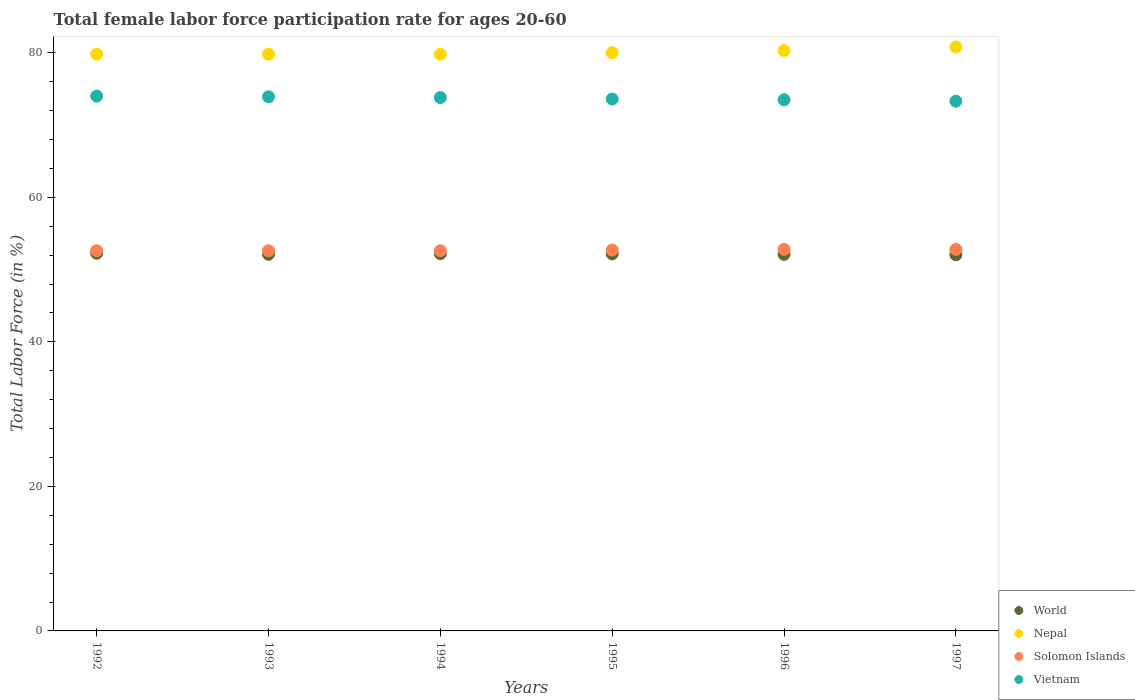How many different coloured dotlines are there?
Your answer should be compact. 4. Is the number of dotlines equal to the number of legend labels?
Keep it short and to the point. Yes. Across all years, what is the maximum female labor force participation rate in World?
Provide a succinct answer. 52.26. Across all years, what is the minimum female labor force participation rate in Solomon Islands?
Your answer should be compact. 52.6. What is the total female labor force participation rate in Nepal in the graph?
Offer a terse response. 480.5. What is the difference between the female labor force participation rate in World in 1995 and that in 1996?
Your answer should be compact. 0.07. What is the difference between the female labor force participation rate in Solomon Islands in 1992 and the female labor force participation rate in Nepal in 1995?
Give a very brief answer. -27.4. What is the average female labor force participation rate in Vietnam per year?
Your response must be concise. 73.68. In the year 1995, what is the difference between the female labor force participation rate in World and female labor force participation rate in Nepal?
Provide a succinct answer. -27.83. What is the ratio of the female labor force participation rate in World in 1992 to that in 1994?
Offer a very short reply. 1. Is the female labor force participation rate in Nepal in 1993 less than that in 1996?
Your response must be concise. Yes. Is the difference between the female labor force participation rate in World in 1993 and 1994 greater than the difference between the female labor force participation rate in Nepal in 1993 and 1994?
Provide a short and direct response. No. What is the difference between the highest and the lowest female labor force participation rate in Solomon Islands?
Your answer should be compact. 0.2. In how many years, is the female labor force participation rate in Nepal greater than the average female labor force participation rate in Nepal taken over all years?
Provide a succinct answer. 2. Does the female labor force participation rate in Vietnam monotonically increase over the years?
Give a very brief answer. No. How many years are there in the graph?
Make the answer very short. 6. Does the graph contain grids?
Your answer should be compact. No. Where does the legend appear in the graph?
Offer a very short reply. Bottom right. How many legend labels are there?
Provide a short and direct response. 4. How are the legend labels stacked?
Your answer should be very brief. Vertical. What is the title of the graph?
Offer a terse response. Total female labor force participation rate for ages 20-60. What is the label or title of the X-axis?
Give a very brief answer. Years. What is the label or title of the Y-axis?
Keep it short and to the point. Total Labor Force (in %). What is the Total Labor Force (in %) of World in 1992?
Provide a short and direct response. 52.26. What is the Total Labor Force (in %) of Nepal in 1992?
Ensure brevity in your answer.  79.8. What is the Total Labor Force (in %) of Solomon Islands in 1992?
Provide a succinct answer. 52.6. What is the Total Labor Force (in %) of World in 1993?
Make the answer very short. 52.11. What is the Total Labor Force (in %) in Nepal in 1993?
Your response must be concise. 79.8. What is the Total Labor Force (in %) in Solomon Islands in 1993?
Provide a succinct answer. 52.6. What is the Total Labor Force (in %) in Vietnam in 1993?
Offer a terse response. 73.9. What is the Total Labor Force (in %) of World in 1994?
Offer a terse response. 52.2. What is the Total Labor Force (in %) of Nepal in 1994?
Make the answer very short. 79.8. What is the Total Labor Force (in %) of Solomon Islands in 1994?
Offer a terse response. 52.6. What is the Total Labor Force (in %) in Vietnam in 1994?
Your response must be concise. 73.8. What is the Total Labor Force (in %) in World in 1995?
Give a very brief answer. 52.17. What is the Total Labor Force (in %) in Solomon Islands in 1995?
Offer a terse response. 52.7. What is the Total Labor Force (in %) of Vietnam in 1995?
Give a very brief answer. 73.6. What is the Total Labor Force (in %) of World in 1996?
Your answer should be very brief. 52.1. What is the Total Labor Force (in %) of Nepal in 1996?
Your answer should be compact. 80.3. What is the Total Labor Force (in %) in Solomon Islands in 1996?
Your answer should be compact. 52.8. What is the Total Labor Force (in %) of Vietnam in 1996?
Your answer should be compact. 73.5. What is the Total Labor Force (in %) of World in 1997?
Offer a very short reply. 52.04. What is the Total Labor Force (in %) of Nepal in 1997?
Offer a terse response. 80.8. What is the Total Labor Force (in %) in Solomon Islands in 1997?
Your answer should be compact. 52.8. What is the Total Labor Force (in %) of Vietnam in 1997?
Ensure brevity in your answer.  73.3. Across all years, what is the maximum Total Labor Force (in %) of World?
Offer a terse response. 52.26. Across all years, what is the maximum Total Labor Force (in %) in Nepal?
Give a very brief answer. 80.8. Across all years, what is the maximum Total Labor Force (in %) in Solomon Islands?
Your answer should be very brief. 52.8. Across all years, what is the maximum Total Labor Force (in %) of Vietnam?
Your response must be concise. 74. Across all years, what is the minimum Total Labor Force (in %) in World?
Your response must be concise. 52.04. Across all years, what is the minimum Total Labor Force (in %) in Nepal?
Ensure brevity in your answer.  79.8. Across all years, what is the minimum Total Labor Force (in %) of Solomon Islands?
Offer a very short reply. 52.6. Across all years, what is the minimum Total Labor Force (in %) in Vietnam?
Your answer should be very brief. 73.3. What is the total Total Labor Force (in %) in World in the graph?
Make the answer very short. 312.89. What is the total Total Labor Force (in %) of Nepal in the graph?
Ensure brevity in your answer.  480.5. What is the total Total Labor Force (in %) in Solomon Islands in the graph?
Provide a succinct answer. 316.1. What is the total Total Labor Force (in %) of Vietnam in the graph?
Your answer should be very brief. 442.1. What is the difference between the Total Labor Force (in %) of World in 1992 and that in 1993?
Your answer should be very brief. 0.15. What is the difference between the Total Labor Force (in %) of Nepal in 1992 and that in 1993?
Provide a short and direct response. 0. What is the difference between the Total Labor Force (in %) of Solomon Islands in 1992 and that in 1993?
Offer a terse response. 0. What is the difference between the Total Labor Force (in %) of World in 1992 and that in 1994?
Your response must be concise. 0.06. What is the difference between the Total Labor Force (in %) in Vietnam in 1992 and that in 1994?
Offer a terse response. 0.2. What is the difference between the Total Labor Force (in %) in World in 1992 and that in 1995?
Ensure brevity in your answer.  0.09. What is the difference between the Total Labor Force (in %) of World in 1992 and that in 1996?
Offer a terse response. 0.16. What is the difference between the Total Labor Force (in %) of Nepal in 1992 and that in 1996?
Make the answer very short. -0.5. What is the difference between the Total Labor Force (in %) of Vietnam in 1992 and that in 1996?
Keep it short and to the point. 0.5. What is the difference between the Total Labor Force (in %) of World in 1992 and that in 1997?
Give a very brief answer. 0.21. What is the difference between the Total Labor Force (in %) in Nepal in 1992 and that in 1997?
Ensure brevity in your answer.  -1. What is the difference between the Total Labor Force (in %) in Vietnam in 1992 and that in 1997?
Your answer should be compact. 0.7. What is the difference between the Total Labor Force (in %) in World in 1993 and that in 1994?
Ensure brevity in your answer.  -0.09. What is the difference between the Total Labor Force (in %) of Nepal in 1993 and that in 1994?
Give a very brief answer. 0. What is the difference between the Total Labor Force (in %) of World in 1993 and that in 1995?
Make the answer very short. -0.06. What is the difference between the Total Labor Force (in %) in Nepal in 1993 and that in 1995?
Your response must be concise. -0.2. What is the difference between the Total Labor Force (in %) of World in 1993 and that in 1996?
Give a very brief answer. 0.01. What is the difference between the Total Labor Force (in %) in Solomon Islands in 1993 and that in 1996?
Offer a very short reply. -0.2. What is the difference between the Total Labor Force (in %) in World in 1993 and that in 1997?
Ensure brevity in your answer.  0.07. What is the difference between the Total Labor Force (in %) in Solomon Islands in 1993 and that in 1997?
Make the answer very short. -0.2. What is the difference between the Total Labor Force (in %) in Vietnam in 1993 and that in 1997?
Give a very brief answer. 0.6. What is the difference between the Total Labor Force (in %) in World in 1994 and that in 1995?
Provide a succinct answer. 0.03. What is the difference between the Total Labor Force (in %) of World in 1994 and that in 1996?
Offer a terse response. 0.1. What is the difference between the Total Labor Force (in %) in Nepal in 1994 and that in 1996?
Provide a succinct answer. -0.5. What is the difference between the Total Labor Force (in %) in World in 1994 and that in 1997?
Make the answer very short. 0.16. What is the difference between the Total Labor Force (in %) in Nepal in 1994 and that in 1997?
Offer a terse response. -1. What is the difference between the Total Labor Force (in %) in World in 1995 and that in 1996?
Offer a very short reply. 0.07. What is the difference between the Total Labor Force (in %) of Nepal in 1995 and that in 1996?
Ensure brevity in your answer.  -0.3. What is the difference between the Total Labor Force (in %) of Vietnam in 1995 and that in 1996?
Keep it short and to the point. 0.1. What is the difference between the Total Labor Force (in %) in World in 1995 and that in 1997?
Offer a terse response. 0.12. What is the difference between the Total Labor Force (in %) in Nepal in 1995 and that in 1997?
Keep it short and to the point. -0.8. What is the difference between the Total Labor Force (in %) of Vietnam in 1995 and that in 1997?
Provide a succinct answer. 0.3. What is the difference between the Total Labor Force (in %) of World in 1996 and that in 1997?
Your answer should be compact. 0.06. What is the difference between the Total Labor Force (in %) in World in 1992 and the Total Labor Force (in %) in Nepal in 1993?
Your answer should be very brief. -27.54. What is the difference between the Total Labor Force (in %) in World in 1992 and the Total Labor Force (in %) in Solomon Islands in 1993?
Offer a very short reply. -0.34. What is the difference between the Total Labor Force (in %) in World in 1992 and the Total Labor Force (in %) in Vietnam in 1993?
Your answer should be compact. -21.64. What is the difference between the Total Labor Force (in %) of Nepal in 1992 and the Total Labor Force (in %) of Solomon Islands in 1993?
Provide a succinct answer. 27.2. What is the difference between the Total Labor Force (in %) in Nepal in 1992 and the Total Labor Force (in %) in Vietnam in 1993?
Offer a terse response. 5.9. What is the difference between the Total Labor Force (in %) of Solomon Islands in 1992 and the Total Labor Force (in %) of Vietnam in 1993?
Ensure brevity in your answer.  -21.3. What is the difference between the Total Labor Force (in %) of World in 1992 and the Total Labor Force (in %) of Nepal in 1994?
Make the answer very short. -27.54. What is the difference between the Total Labor Force (in %) of World in 1992 and the Total Labor Force (in %) of Solomon Islands in 1994?
Your answer should be compact. -0.34. What is the difference between the Total Labor Force (in %) in World in 1992 and the Total Labor Force (in %) in Vietnam in 1994?
Ensure brevity in your answer.  -21.54. What is the difference between the Total Labor Force (in %) of Nepal in 1992 and the Total Labor Force (in %) of Solomon Islands in 1994?
Give a very brief answer. 27.2. What is the difference between the Total Labor Force (in %) in Nepal in 1992 and the Total Labor Force (in %) in Vietnam in 1994?
Provide a short and direct response. 6. What is the difference between the Total Labor Force (in %) of Solomon Islands in 1992 and the Total Labor Force (in %) of Vietnam in 1994?
Your answer should be very brief. -21.2. What is the difference between the Total Labor Force (in %) in World in 1992 and the Total Labor Force (in %) in Nepal in 1995?
Make the answer very short. -27.74. What is the difference between the Total Labor Force (in %) of World in 1992 and the Total Labor Force (in %) of Solomon Islands in 1995?
Offer a terse response. -0.44. What is the difference between the Total Labor Force (in %) in World in 1992 and the Total Labor Force (in %) in Vietnam in 1995?
Keep it short and to the point. -21.34. What is the difference between the Total Labor Force (in %) of Nepal in 1992 and the Total Labor Force (in %) of Solomon Islands in 1995?
Your answer should be very brief. 27.1. What is the difference between the Total Labor Force (in %) of Nepal in 1992 and the Total Labor Force (in %) of Vietnam in 1995?
Provide a short and direct response. 6.2. What is the difference between the Total Labor Force (in %) in Solomon Islands in 1992 and the Total Labor Force (in %) in Vietnam in 1995?
Your response must be concise. -21. What is the difference between the Total Labor Force (in %) in World in 1992 and the Total Labor Force (in %) in Nepal in 1996?
Your answer should be compact. -28.04. What is the difference between the Total Labor Force (in %) of World in 1992 and the Total Labor Force (in %) of Solomon Islands in 1996?
Ensure brevity in your answer.  -0.54. What is the difference between the Total Labor Force (in %) in World in 1992 and the Total Labor Force (in %) in Vietnam in 1996?
Make the answer very short. -21.24. What is the difference between the Total Labor Force (in %) of Nepal in 1992 and the Total Labor Force (in %) of Solomon Islands in 1996?
Give a very brief answer. 27. What is the difference between the Total Labor Force (in %) in Solomon Islands in 1992 and the Total Labor Force (in %) in Vietnam in 1996?
Give a very brief answer. -20.9. What is the difference between the Total Labor Force (in %) of World in 1992 and the Total Labor Force (in %) of Nepal in 1997?
Provide a succinct answer. -28.54. What is the difference between the Total Labor Force (in %) in World in 1992 and the Total Labor Force (in %) in Solomon Islands in 1997?
Keep it short and to the point. -0.54. What is the difference between the Total Labor Force (in %) in World in 1992 and the Total Labor Force (in %) in Vietnam in 1997?
Make the answer very short. -21.04. What is the difference between the Total Labor Force (in %) in Nepal in 1992 and the Total Labor Force (in %) in Solomon Islands in 1997?
Provide a succinct answer. 27. What is the difference between the Total Labor Force (in %) in Solomon Islands in 1992 and the Total Labor Force (in %) in Vietnam in 1997?
Make the answer very short. -20.7. What is the difference between the Total Labor Force (in %) in World in 1993 and the Total Labor Force (in %) in Nepal in 1994?
Provide a short and direct response. -27.69. What is the difference between the Total Labor Force (in %) of World in 1993 and the Total Labor Force (in %) of Solomon Islands in 1994?
Your answer should be very brief. -0.49. What is the difference between the Total Labor Force (in %) in World in 1993 and the Total Labor Force (in %) in Vietnam in 1994?
Make the answer very short. -21.69. What is the difference between the Total Labor Force (in %) in Nepal in 1993 and the Total Labor Force (in %) in Solomon Islands in 1994?
Offer a terse response. 27.2. What is the difference between the Total Labor Force (in %) in Solomon Islands in 1993 and the Total Labor Force (in %) in Vietnam in 1994?
Offer a very short reply. -21.2. What is the difference between the Total Labor Force (in %) in World in 1993 and the Total Labor Force (in %) in Nepal in 1995?
Your answer should be compact. -27.89. What is the difference between the Total Labor Force (in %) of World in 1993 and the Total Labor Force (in %) of Solomon Islands in 1995?
Make the answer very short. -0.59. What is the difference between the Total Labor Force (in %) of World in 1993 and the Total Labor Force (in %) of Vietnam in 1995?
Ensure brevity in your answer.  -21.49. What is the difference between the Total Labor Force (in %) of Nepal in 1993 and the Total Labor Force (in %) of Solomon Islands in 1995?
Give a very brief answer. 27.1. What is the difference between the Total Labor Force (in %) of Nepal in 1993 and the Total Labor Force (in %) of Vietnam in 1995?
Offer a terse response. 6.2. What is the difference between the Total Labor Force (in %) in Solomon Islands in 1993 and the Total Labor Force (in %) in Vietnam in 1995?
Your answer should be very brief. -21. What is the difference between the Total Labor Force (in %) in World in 1993 and the Total Labor Force (in %) in Nepal in 1996?
Offer a very short reply. -28.19. What is the difference between the Total Labor Force (in %) of World in 1993 and the Total Labor Force (in %) of Solomon Islands in 1996?
Ensure brevity in your answer.  -0.69. What is the difference between the Total Labor Force (in %) of World in 1993 and the Total Labor Force (in %) of Vietnam in 1996?
Your response must be concise. -21.39. What is the difference between the Total Labor Force (in %) of Solomon Islands in 1993 and the Total Labor Force (in %) of Vietnam in 1996?
Keep it short and to the point. -20.9. What is the difference between the Total Labor Force (in %) of World in 1993 and the Total Labor Force (in %) of Nepal in 1997?
Give a very brief answer. -28.69. What is the difference between the Total Labor Force (in %) of World in 1993 and the Total Labor Force (in %) of Solomon Islands in 1997?
Keep it short and to the point. -0.69. What is the difference between the Total Labor Force (in %) of World in 1993 and the Total Labor Force (in %) of Vietnam in 1997?
Keep it short and to the point. -21.19. What is the difference between the Total Labor Force (in %) in Nepal in 1993 and the Total Labor Force (in %) in Vietnam in 1997?
Your answer should be very brief. 6.5. What is the difference between the Total Labor Force (in %) of Solomon Islands in 1993 and the Total Labor Force (in %) of Vietnam in 1997?
Your answer should be compact. -20.7. What is the difference between the Total Labor Force (in %) of World in 1994 and the Total Labor Force (in %) of Nepal in 1995?
Make the answer very short. -27.8. What is the difference between the Total Labor Force (in %) in World in 1994 and the Total Labor Force (in %) in Solomon Islands in 1995?
Ensure brevity in your answer.  -0.5. What is the difference between the Total Labor Force (in %) of World in 1994 and the Total Labor Force (in %) of Vietnam in 1995?
Your answer should be compact. -21.4. What is the difference between the Total Labor Force (in %) in Nepal in 1994 and the Total Labor Force (in %) in Solomon Islands in 1995?
Offer a very short reply. 27.1. What is the difference between the Total Labor Force (in %) of World in 1994 and the Total Labor Force (in %) of Nepal in 1996?
Make the answer very short. -28.1. What is the difference between the Total Labor Force (in %) of World in 1994 and the Total Labor Force (in %) of Solomon Islands in 1996?
Make the answer very short. -0.6. What is the difference between the Total Labor Force (in %) in World in 1994 and the Total Labor Force (in %) in Vietnam in 1996?
Provide a succinct answer. -21.3. What is the difference between the Total Labor Force (in %) in Solomon Islands in 1994 and the Total Labor Force (in %) in Vietnam in 1996?
Provide a succinct answer. -20.9. What is the difference between the Total Labor Force (in %) of World in 1994 and the Total Labor Force (in %) of Nepal in 1997?
Ensure brevity in your answer.  -28.6. What is the difference between the Total Labor Force (in %) of World in 1994 and the Total Labor Force (in %) of Solomon Islands in 1997?
Provide a short and direct response. -0.6. What is the difference between the Total Labor Force (in %) in World in 1994 and the Total Labor Force (in %) in Vietnam in 1997?
Your answer should be very brief. -21.1. What is the difference between the Total Labor Force (in %) of Nepal in 1994 and the Total Labor Force (in %) of Solomon Islands in 1997?
Give a very brief answer. 27. What is the difference between the Total Labor Force (in %) in Solomon Islands in 1994 and the Total Labor Force (in %) in Vietnam in 1997?
Give a very brief answer. -20.7. What is the difference between the Total Labor Force (in %) of World in 1995 and the Total Labor Force (in %) of Nepal in 1996?
Provide a short and direct response. -28.13. What is the difference between the Total Labor Force (in %) of World in 1995 and the Total Labor Force (in %) of Solomon Islands in 1996?
Your answer should be compact. -0.63. What is the difference between the Total Labor Force (in %) of World in 1995 and the Total Labor Force (in %) of Vietnam in 1996?
Your answer should be compact. -21.33. What is the difference between the Total Labor Force (in %) of Nepal in 1995 and the Total Labor Force (in %) of Solomon Islands in 1996?
Offer a terse response. 27.2. What is the difference between the Total Labor Force (in %) of Nepal in 1995 and the Total Labor Force (in %) of Vietnam in 1996?
Ensure brevity in your answer.  6.5. What is the difference between the Total Labor Force (in %) in Solomon Islands in 1995 and the Total Labor Force (in %) in Vietnam in 1996?
Ensure brevity in your answer.  -20.8. What is the difference between the Total Labor Force (in %) of World in 1995 and the Total Labor Force (in %) of Nepal in 1997?
Offer a terse response. -28.63. What is the difference between the Total Labor Force (in %) in World in 1995 and the Total Labor Force (in %) in Solomon Islands in 1997?
Provide a succinct answer. -0.63. What is the difference between the Total Labor Force (in %) in World in 1995 and the Total Labor Force (in %) in Vietnam in 1997?
Offer a very short reply. -21.13. What is the difference between the Total Labor Force (in %) of Nepal in 1995 and the Total Labor Force (in %) of Solomon Islands in 1997?
Ensure brevity in your answer.  27.2. What is the difference between the Total Labor Force (in %) of Nepal in 1995 and the Total Labor Force (in %) of Vietnam in 1997?
Provide a short and direct response. 6.7. What is the difference between the Total Labor Force (in %) of Solomon Islands in 1995 and the Total Labor Force (in %) of Vietnam in 1997?
Make the answer very short. -20.6. What is the difference between the Total Labor Force (in %) in World in 1996 and the Total Labor Force (in %) in Nepal in 1997?
Offer a very short reply. -28.7. What is the difference between the Total Labor Force (in %) of World in 1996 and the Total Labor Force (in %) of Solomon Islands in 1997?
Give a very brief answer. -0.7. What is the difference between the Total Labor Force (in %) in World in 1996 and the Total Labor Force (in %) in Vietnam in 1997?
Provide a succinct answer. -21.2. What is the difference between the Total Labor Force (in %) of Nepal in 1996 and the Total Labor Force (in %) of Solomon Islands in 1997?
Ensure brevity in your answer.  27.5. What is the difference between the Total Labor Force (in %) in Nepal in 1996 and the Total Labor Force (in %) in Vietnam in 1997?
Offer a terse response. 7. What is the difference between the Total Labor Force (in %) of Solomon Islands in 1996 and the Total Labor Force (in %) of Vietnam in 1997?
Provide a short and direct response. -20.5. What is the average Total Labor Force (in %) in World per year?
Make the answer very short. 52.15. What is the average Total Labor Force (in %) of Nepal per year?
Provide a short and direct response. 80.08. What is the average Total Labor Force (in %) of Solomon Islands per year?
Give a very brief answer. 52.68. What is the average Total Labor Force (in %) in Vietnam per year?
Your answer should be compact. 73.68. In the year 1992, what is the difference between the Total Labor Force (in %) in World and Total Labor Force (in %) in Nepal?
Offer a very short reply. -27.54. In the year 1992, what is the difference between the Total Labor Force (in %) of World and Total Labor Force (in %) of Solomon Islands?
Provide a succinct answer. -0.34. In the year 1992, what is the difference between the Total Labor Force (in %) of World and Total Labor Force (in %) of Vietnam?
Provide a short and direct response. -21.74. In the year 1992, what is the difference between the Total Labor Force (in %) of Nepal and Total Labor Force (in %) of Solomon Islands?
Your answer should be compact. 27.2. In the year 1992, what is the difference between the Total Labor Force (in %) of Solomon Islands and Total Labor Force (in %) of Vietnam?
Offer a very short reply. -21.4. In the year 1993, what is the difference between the Total Labor Force (in %) in World and Total Labor Force (in %) in Nepal?
Make the answer very short. -27.69. In the year 1993, what is the difference between the Total Labor Force (in %) of World and Total Labor Force (in %) of Solomon Islands?
Your response must be concise. -0.49. In the year 1993, what is the difference between the Total Labor Force (in %) of World and Total Labor Force (in %) of Vietnam?
Provide a succinct answer. -21.79. In the year 1993, what is the difference between the Total Labor Force (in %) in Nepal and Total Labor Force (in %) in Solomon Islands?
Your response must be concise. 27.2. In the year 1993, what is the difference between the Total Labor Force (in %) in Solomon Islands and Total Labor Force (in %) in Vietnam?
Offer a terse response. -21.3. In the year 1994, what is the difference between the Total Labor Force (in %) in World and Total Labor Force (in %) in Nepal?
Make the answer very short. -27.6. In the year 1994, what is the difference between the Total Labor Force (in %) of World and Total Labor Force (in %) of Solomon Islands?
Make the answer very short. -0.4. In the year 1994, what is the difference between the Total Labor Force (in %) of World and Total Labor Force (in %) of Vietnam?
Your answer should be very brief. -21.6. In the year 1994, what is the difference between the Total Labor Force (in %) of Nepal and Total Labor Force (in %) of Solomon Islands?
Give a very brief answer. 27.2. In the year 1994, what is the difference between the Total Labor Force (in %) in Solomon Islands and Total Labor Force (in %) in Vietnam?
Provide a short and direct response. -21.2. In the year 1995, what is the difference between the Total Labor Force (in %) in World and Total Labor Force (in %) in Nepal?
Your response must be concise. -27.83. In the year 1995, what is the difference between the Total Labor Force (in %) of World and Total Labor Force (in %) of Solomon Islands?
Provide a short and direct response. -0.53. In the year 1995, what is the difference between the Total Labor Force (in %) in World and Total Labor Force (in %) in Vietnam?
Make the answer very short. -21.43. In the year 1995, what is the difference between the Total Labor Force (in %) of Nepal and Total Labor Force (in %) of Solomon Islands?
Your answer should be very brief. 27.3. In the year 1995, what is the difference between the Total Labor Force (in %) in Solomon Islands and Total Labor Force (in %) in Vietnam?
Provide a succinct answer. -20.9. In the year 1996, what is the difference between the Total Labor Force (in %) of World and Total Labor Force (in %) of Nepal?
Provide a short and direct response. -28.2. In the year 1996, what is the difference between the Total Labor Force (in %) of World and Total Labor Force (in %) of Solomon Islands?
Ensure brevity in your answer.  -0.7. In the year 1996, what is the difference between the Total Labor Force (in %) of World and Total Labor Force (in %) of Vietnam?
Provide a succinct answer. -21.4. In the year 1996, what is the difference between the Total Labor Force (in %) in Solomon Islands and Total Labor Force (in %) in Vietnam?
Make the answer very short. -20.7. In the year 1997, what is the difference between the Total Labor Force (in %) in World and Total Labor Force (in %) in Nepal?
Make the answer very short. -28.76. In the year 1997, what is the difference between the Total Labor Force (in %) in World and Total Labor Force (in %) in Solomon Islands?
Keep it short and to the point. -0.76. In the year 1997, what is the difference between the Total Labor Force (in %) in World and Total Labor Force (in %) in Vietnam?
Keep it short and to the point. -21.26. In the year 1997, what is the difference between the Total Labor Force (in %) of Nepal and Total Labor Force (in %) of Solomon Islands?
Make the answer very short. 28. In the year 1997, what is the difference between the Total Labor Force (in %) in Solomon Islands and Total Labor Force (in %) in Vietnam?
Your answer should be very brief. -20.5. What is the ratio of the Total Labor Force (in %) in World in 1992 to that in 1993?
Provide a short and direct response. 1. What is the ratio of the Total Labor Force (in %) of Solomon Islands in 1992 to that in 1993?
Provide a short and direct response. 1. What is the ratio of the Total Labor Force (in %) in Vietnam in 1992 to that in 1993?
Ensure brevity in your answer.  1. What is the ratio of the Total Labor Force (in %) of World in 1992 to that in 1994?
Provide a succinct answer. 1. What is the ratio of the Total Labor Force (in %) of Solomon Islands in 1992 to that in 1994?
Your answer should be compact. 1. What is the ratio of the Total Labor Force (in %) in World in 1992 to that in 1995?
Keep it short and to the point. 1. What is the ratio of the Total Labor Force (in %) of Nepal in 1992 to that in 1995?
Offer a terse response. 1. What is the ratio of the Total Labor Force (in %) in Solomon Islands in 1992 to that in 1995?
Offer a terse response. 1. What is the ratio of the Total Labor Force (in %) of Vietnam in 1992 to that in 1995?
Ensure brevity in your answer.  1.01. What is the ratio of the Total Labor Force (in %) of World in 1992 to that in 1996?
Ensure brevity in your answer.  1. What is the ratio of the Total Labor Force (in %) of Solomon Islands in 1992 to that in 1996?
Give a very brief answer. 1. What is the ratio of the Total Labor Force (in %) of Vietnam in 1992 to that in 1996?
Provide a succinct answer. 1.01. What is the ratio of the Total Labor Force (in %) in World in 1992 to that in 1997?
Your answer should be compact. 1. What is the ratio of the Total Labor Force (in %) in Nepal in 1992 to that in 1997?
Provide a short and direct response. 0.99. What is the ratio of the Total Labor Force (in %) in Solomon Islands in 1992 to that in 1997?
Provide a short and direct response. 1. What is the ratio of the Total Labor Force (in %) in Vietnam in 1992 to that in 1997?
Keep it short and to the point. 1.01. What is the ratio of the Total Labor Force (in %) of World in 1993 to that in 1994?
Make the answer very short. 1. What is the ratio of the Total Labor Force (in %) of Nepal in 1993 to that in 1994?
Your answer should be very brief. 1. What is the ratio of the Total Labor Force (in %) in Vietnam in 1993 to that in 1994?
Make the answer very short. 1. What is the ratio of the Total Labor Force (in %) of World in 1993 to that in 1996?
Your response must be concise. 1. What is the ratio of the Total Labor Force (in %) of Vietnam in 1993 to that in 1996?
Provide a short and direct response. 1.01. What is the ratio of the Total Labor Force (in %) in Nepal in 1993 to that in 1997?
Ensure brevity in your answer.  0.99. What is the ratio of the Total Labor Force (in %) in Solomon Islands in 1993 to that in 1997?
Make the answer very short. 1. What is the ratio of the Total Labor Force (in %) of Vietnam in 1993 to that in 1997?
Ensure brevity in your answer.  1.01. What is the ratio of the Total Labor Force (in %) in World in 1994 to that in 1996?
Your response must be concise. 1. What is the ratio of the Total Labor Force (in %) of Nepal in 1994 to that in 1996?
Your response must be concise. 0.99. What is the ratio of the Total Labor Force (in %) of Vietnam in 1994 to that in 1996?
Your answer should be compact. 1. What is the ratio of the Total Labor Force (in %) of Nepal in 1994 to that in 1997?
Make the answer very short. 0.99. What is the ratio of the Total Labor Force (in %) in Solomon Islands in 1994 to that in 1997?
Ensure brevity in your answer.  1. What is the ratio of the Total Labor Force (in %) of Vietnam in 1994 to that in 1997?
Provide a short and direct response. 1.01. What is the ratio of the Total Labor Force (in %) in Nepal in 1995 to that in 1996?
Offer a terse response. 1. What is the ratio of the Total Labor Force (in %) of Solomon Islands in 1995 to that in 1996?
Your answer should be compact. 1. What is the ratio of the Total Labor Force (in %) in World in 1995 to that in 1997?
Your response must be concise. 1. What is the ratio of the Total Labor Force (in %) in Nepal in 1995 to that in 1997?
Your response must be concise. 0.99. What is the ratio of the Total Labor Force (in %) of Solomon Islands in 1995 to that in 1997?
Provide a short and direct response. 1. What is the ratio of the Total Labor Force (in %) in World in 1996 to that in 1997?
Provide a short and direct response. 1. What is the ratio of the Total Labor Force (in %) of Vietnam in 1996 to that in 1997?
Offer a very short reply. 1. What is the difference between the highest and the second highest Total Labor Force (in %) of World?
Keep it short and to the point. 0.06. What is the difference between the highest and the second highest Total Labor Force (in %) of Solomon Islands?
Provide a short and direct response. 0. What is the difference between the highest and the second highest Total Labor Force (in %) of Vietnam?
Keep it short and to the point. 0.1. What is the difference between the highest and the lowest Total Labor Force (in %) of World?
Ensure brevity in your answer.  0.21. What is the difference between the highest and the lowest Total Labor Force (in %) of Nepal?
Your answer should be very brief. 1. What is the difference between the highest and the lowest Total Labor Force (in %) in Vietnam?
Provide a succinct answer. 0.7. 